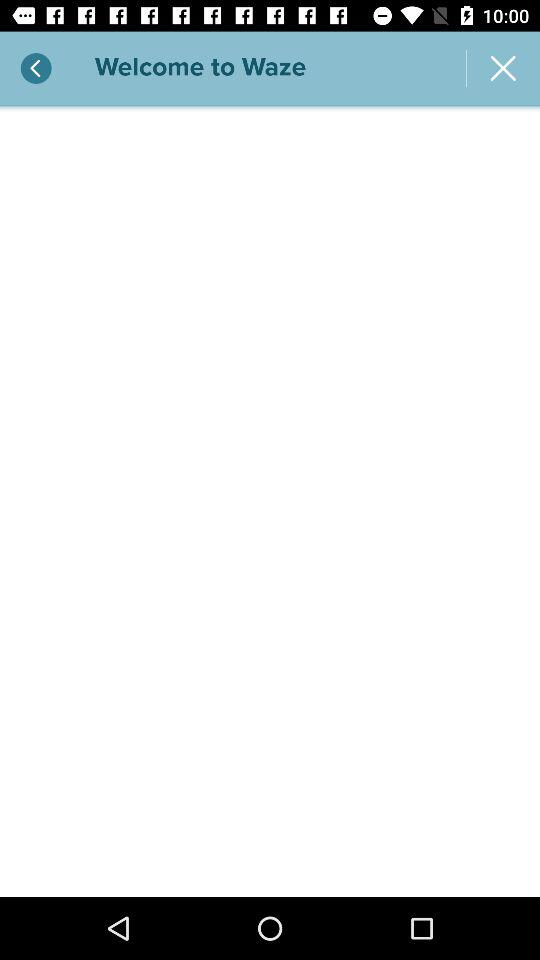What is the name of the application? The name of the application is "Waze". 